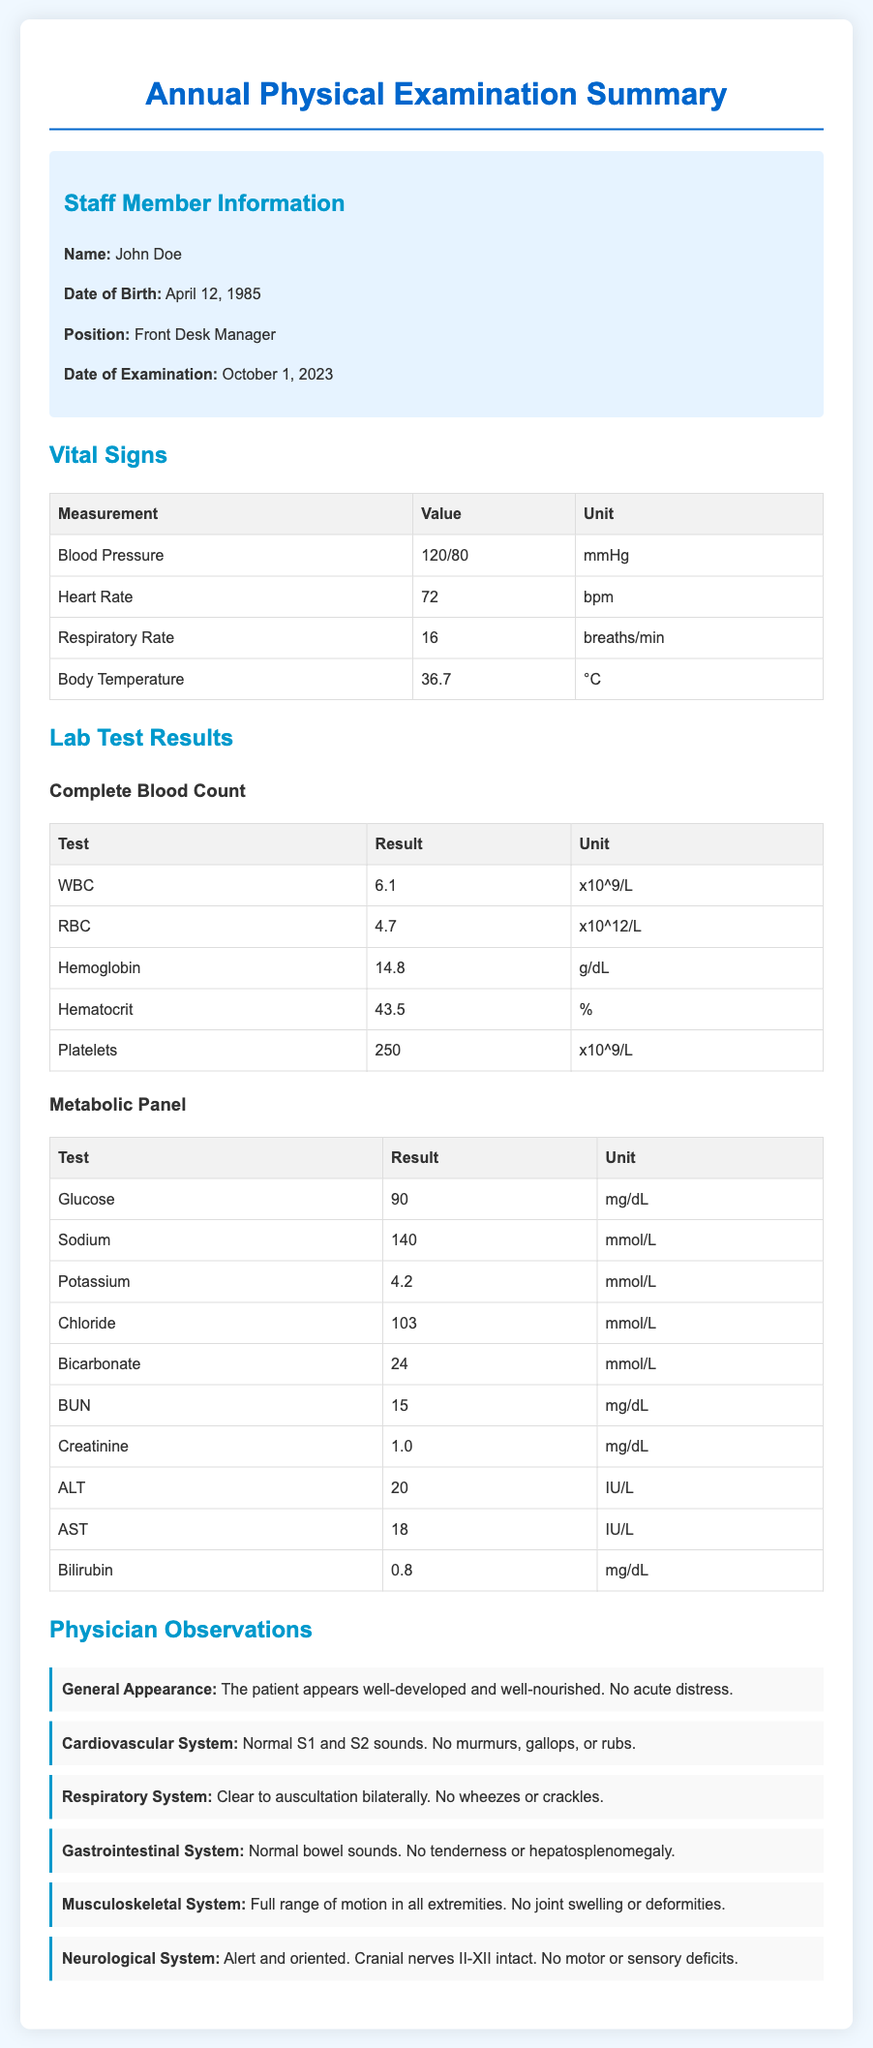What is the name of the staff member? The document specifies the staff member's name as John Doe.
Answer: John Doe What is the date of the examination? The examination date listed in the document is October 1, 2023.
Answer: October 1, 2023 What is the blood pressure reading? The blood pressure value noted in the vital signs section is 120/80 mmHg.
Answer: 120/80 mmHg What is the heart rate? The document records the heart rate as 72 bpm.
Answer: 72 bpm How many observations are made by the physician? The physician makes six observations regarding different systems of the body.
Answer: six What is the result of the Glucose test? According to the lab results, the Glucose test result is 90 mg/dL.
Answer: 90 mg/dL What does the physician note about the cardiovascular system? The physician notes normal S1 and S2 sounds with no murmurs, gallops, or rubs.
Answer: Normal S1 and S2 sounds. No murmurs, gallops, or rubs What is the result for Hemoglobin in the complete blood count? The Hemoglobin level recorded in the document is 14.8 g/dL.
Answer: 14.8 g/dL What system shows full range of motion in the observations? The musculoskeletal system is noted to have full range of motion in all extremities.
Answer: Musculoskeletal System 